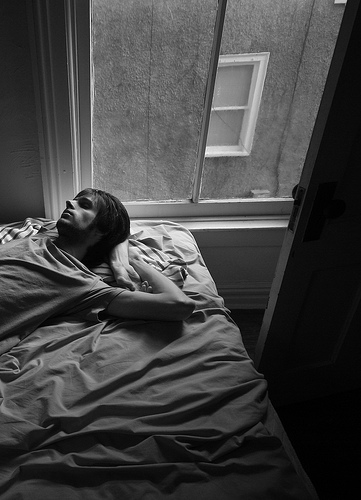Describe the environment outside the window. The environment outside the window seems calm and residential. There's a building with a window visible, it looks like it could be part of an apartment complex. 